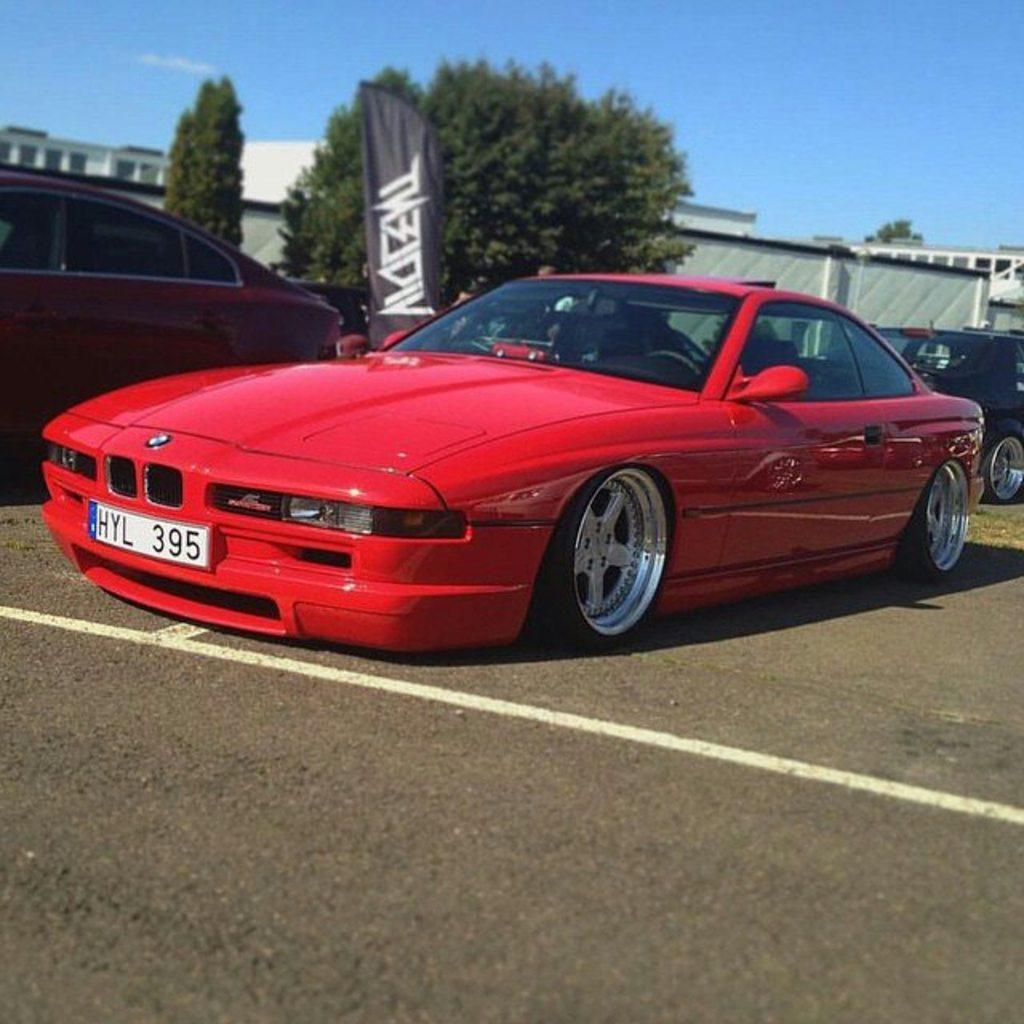What can be seen on the road in the image? There are vehicles on the road in the image. What type of natural elements are present in the image? There are trees in the image. What type of man-made structures are present in the image? There are buildings in the image. What type of advertising element is present in the image? There is an advertising flag in the image. What is visible in the background of the image? The sky is visible in the background of the image. What type of muscle is being flexed by the tree in the image? There are no muscles present in the image, as it features vehicles, trees, buildings, an advertising flag, and the sky. What type of stamp can be seen on the building in the image? There are no stamps present on any of the buildings in the image. 